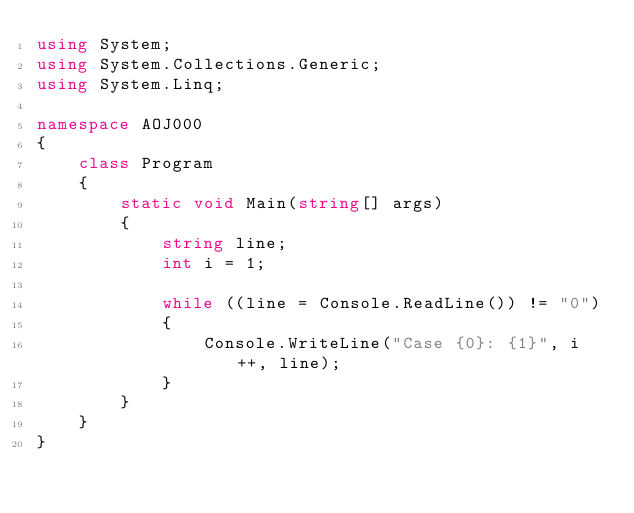<code> <loc_0><loc_0><loc_500><loc_500><_C#_>using System;
using System.Collections.Generic;
using System.Linq;

namespace AOJ000
{
    class Program
    {
        static void Main(string[] args)
        {
            string line;
            int i = 1;

            while ((line = Console.ReadLine()) != "0")
            {
                Console.WriteLine("Case {0}: {1}", i++, line);
            }
        }
    }
}</code> 